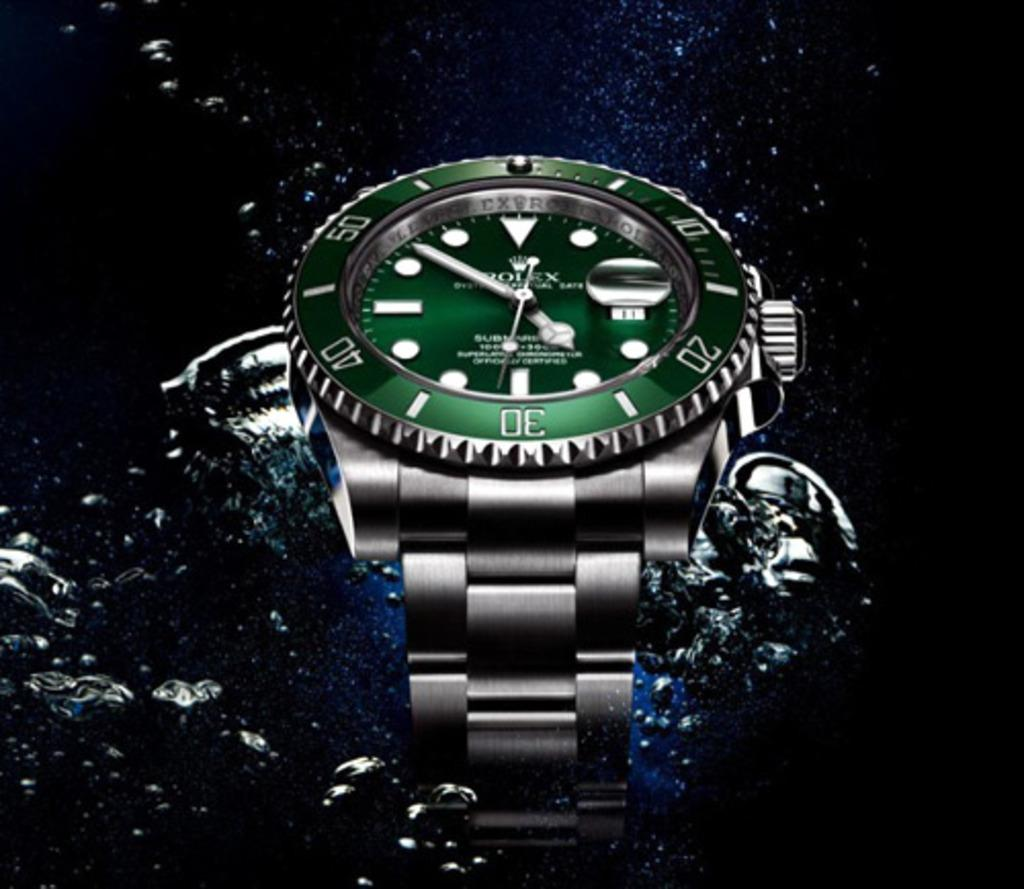<image>
Offer a succinct explanation of the picture presented. the rolex watch with a green face is in wat 